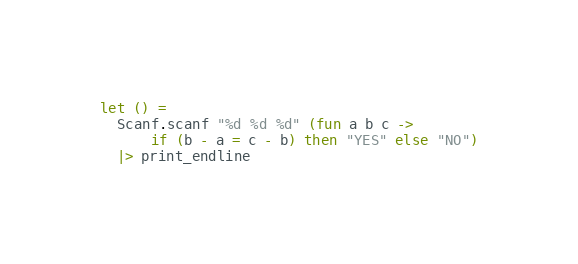Convert code to text. <code><loc_0><loc_0><loc_500><loc_500><_OCaml_>let () = 
  Scanf.scanf "%d %d %d" (fun a b c ->
      if (b - a = c - b) then "YES" else "NO")
  |> print_endline</code> 